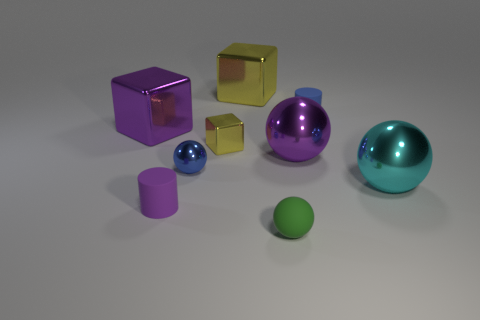Subtract all green balls. How many balls are left? 3 Subtract all cyan spheres. How many spheres are left? 3 Add 1 big yellow rubber objects. How many objects exist? 10 Subtract all red spheres. Subtract all blue cylinders. How many spheres are left? 4 Subtract all balls. How many objects are left? 5 Add 2 large yellow metallic blocks. How many large yellow metallic blocks exist? 3 Subtract 1 purple cylinders. How many objects are left? 8 Subtract all cyan spheres. Subtract all large yellow shiny cubes. How many objects are left? 7 Add 4 purple matte objects. How many purple matte objects are left? 5 